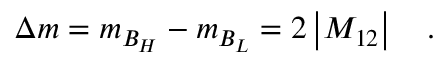Convert formula to latex. <formula><loc_0><loc_0><loc_500><loc_500>\Delta m = m _ { B _ { H } } - m _ { B _ { L } } = 2 \left | M _ { 1 2 } \right | .</formula> 